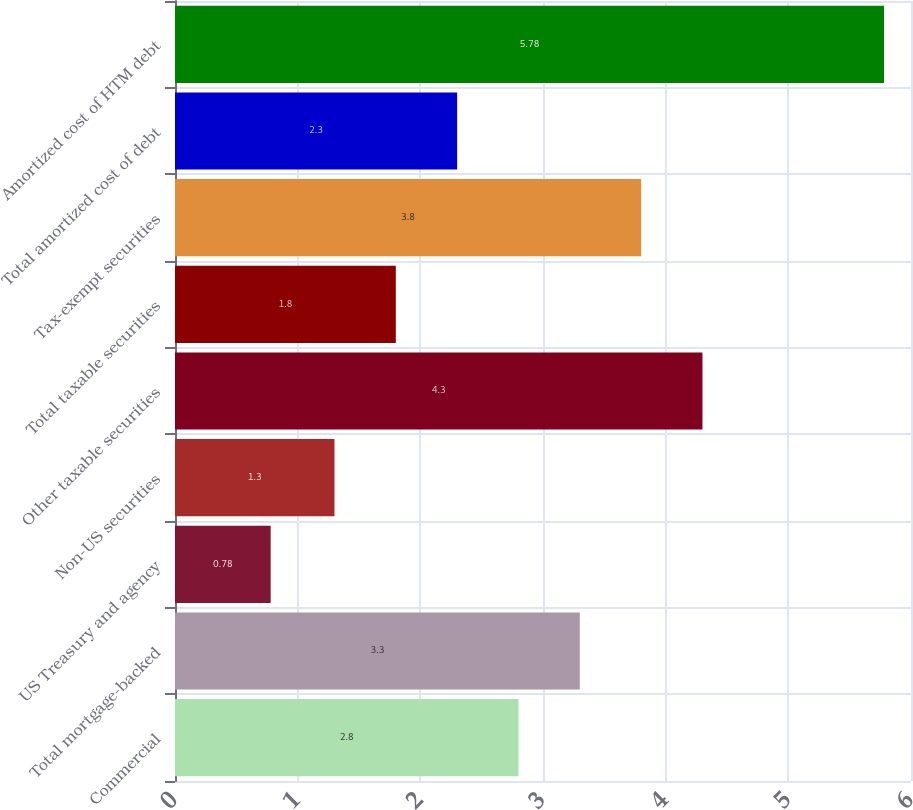<chart> <loc_0><loc_0><loc_500><loc_500><bar_chart><fcel>Commercial<fcel>Total mortgage-backed<fcel>US Treasury and agency<fcel>Non-US securities<fcel>Other taxable securities<fcel>Total taxable securities<fcel>Tax-exempt securities<fcel>Total amortized cost of debt<fcel>Amortized cost of HTM debt<nl><fcel>2.8<fcel>3.3<fcel>0.78<fcel>1.3<fcel>4.3<fcel>1.8<fcel>3.8<fcel>2.3<fcel>5.78<nl></chart> 